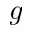<formula> <loc_0><loc_0><loc_500><loc_500>g</formula> 